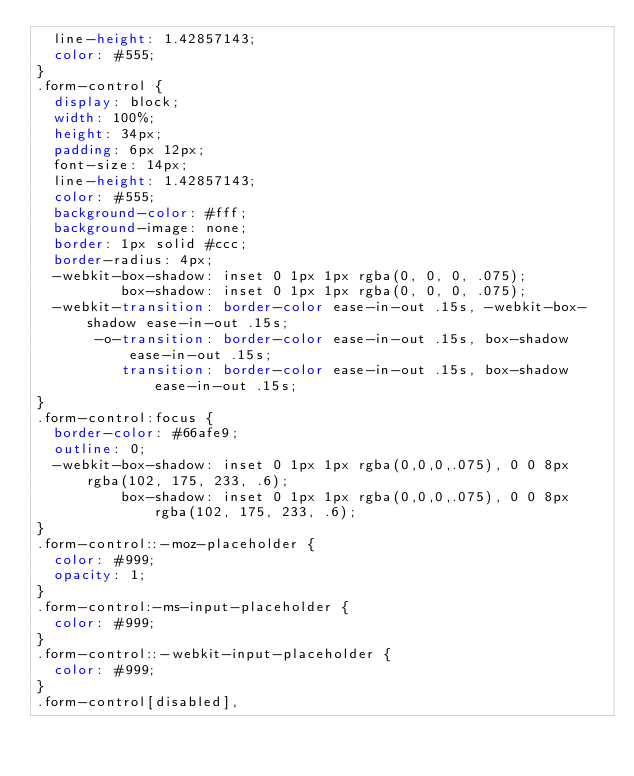<code> <loc_0><loc_0><loc_500><loc_500><_CSS_>  line-height: 1.42857143;
  color: #555;
}
.form-control {
  display: block;
  width: 100%;
  height: 34px;
  padding: 6px 12px;
  font-size: 14px;
  line-height: 1.42857143;
  color: #555;
  background-color: #fff;
  background-image: none;
  border: 1px solid #ccc;
  border-radius: 4px;
  -webkit-box-shadow: inset 0 1px 1px rgba(0, 0, 0, .075);
          box-shadow: inset 0 1px 1px rgba(0, 0, 0, .075);
  -webkit-transition: border-color ease-in-out .15s, -webkit-box-shadow ease-in-out .15s;
       -o-transition: border-color ease-in-out .15s, box-shadow ease-in-out .15s;
          transition: border-color ease-in-out .15s, box-shadow ease-in-out .15s;
}
.form-control:focus {
  border-color: #66afe9;
  outline: 0;
  -webkit-box-shadow: inset 0 1px 1px rgba(0,0,0,.075), 0 0 8px rgba(102, 175, 233, .6);
          box-shadow: inset 0 1px 1px rgba(0,0,0,.075), 0 0 8px rgba(102, 175, 233, .6);
}
.form-control::-moz-placeholder {
  color: #999;
  opacity: 1;
}
.form-control:-ms-input-placeholder {
  color: #999;
}
.form-control::-webkit-input-placeholder {
  color: #999;
}
.form-control[disabled],</code> 